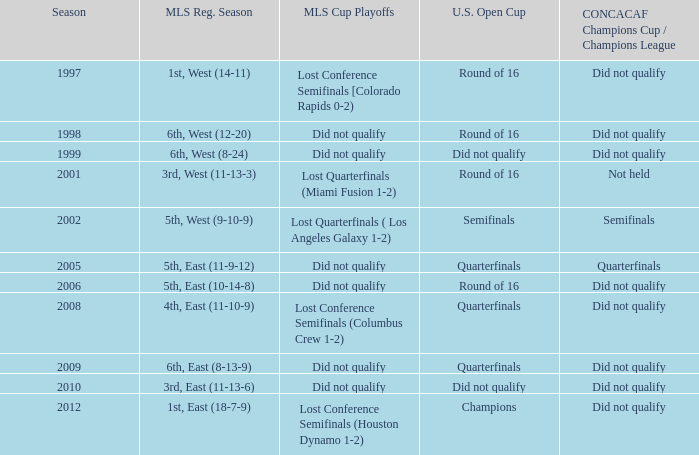What was the team's position when they failed to qualify for the concaf champions cup but reached the round of 16 in the u.s. open cup? Lost Conference Semifinals [Colorado Rapids 0-2), Did not qualify, Did not qualify. 